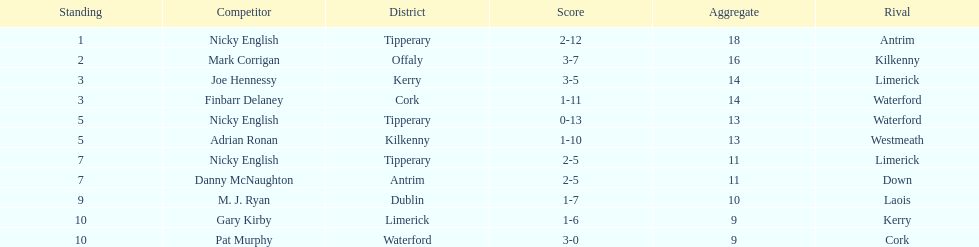How many people are on the list? 9. 